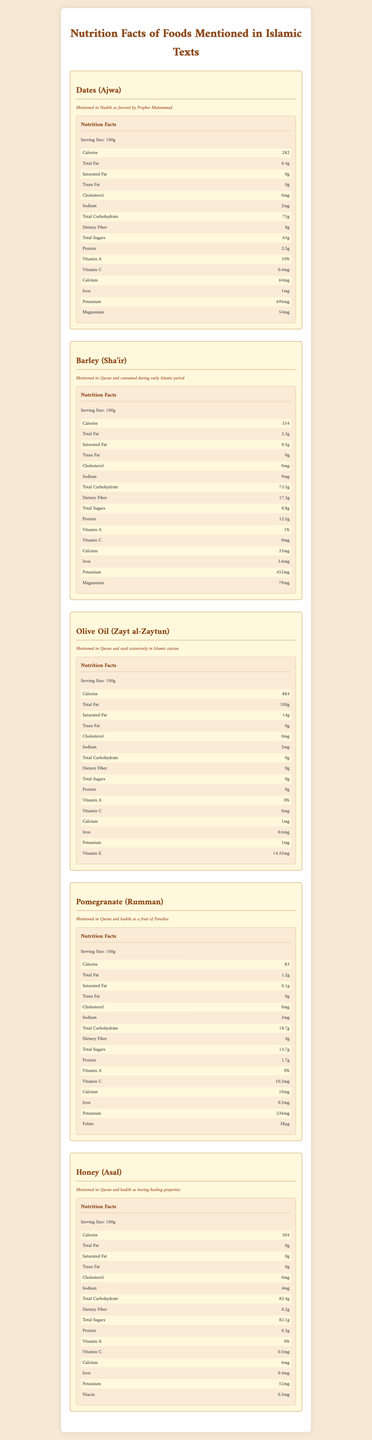what is the serving size for Dates (Ajwa)? The serving size is listed as 100g in the nutrition facts section for Dates (Ajwa).
Answer: 100g how much protein does Barley (Sha'ir) contain per serving? The nutrition facts section for Barley indicates that it contains 12.5g of protein per 100g serving.
Answer: 12.5g what is the total calorie content in Olive Oil (Zayt al-Zaytun)? The total calorie content for Olive Oil (Zayt al-Zaytun) per 100g serving is listed as 884 calories.
Answer: 884 how many milligrams of potassium are present in Pomegranate (Rumman)? The nutrition facts section for Pomegranate indicates it contains 236mg of potassium per 100g serving.
Answer: 236mg what is the amount of dietary fiber in Honey (Asal)? The nutrition facts section for Honey lists the dietary fiber content as 0.2g per 100g serving.
Answer: 0.2g What food item has the highest iron content per serving? A. Dates (Ajwa) B. Barley (Sha'ir) C. Olive Oil (Zayt al-Zaytun) D. Pomegranate (Rumman) E. Honey (Asal) Barley contains 3.6mg of iron per 100g serving, which is higher than the iron content in the other listed food items.
Answer: B. Barley (Sha'ir) Which of the following foods have zero cholesterol? I. Dates (Ajwa) II. Barley (Sha'ir) III. Olive Oil (Zayt al-Zaytun) IV. Pomegranate (Rumman) V. Honey (Asal) All the listed food items report having 0mg of cholesterol per 100g serving.
Answer: I, II, III, IV, and V Is Olive Oil (Zayt al-Zaytun) a good source of vitamin C? Olive Oil (Zayt al-Zaytun) contains 0mg of vitamin C per 100g serving, so it is not a source of vitamin C.
Answer: No Summarize the main idea of the document. The document combines historical references with modern nutritional data to give a comprehensive overview of the nutritional value of foods significant in Islamic culture.
Answer: The document provides an overview of the nutritional content of various foods mentioned in Islamic historical texts, such as Dates, Barley, Olive Oil, Pomegranate, and Honey. It includes detailed information on serving size, calories, fats, cholesterol, sodium, carbohydrates, fibers, sugars, proteins, and various vitamins and minerals. Each food item is accompanied by its historical context and its significance in Islamic tradition. What are the traditional uses of Dates (Ajwa) in Islamic texts? The document provides nutritional information and mentions that Dates (Ajwa) were favored by Prophet Muhammad as noted in Hadith, but it does not elaborate on traditional uses or recipes.
Answer: Not enough information 